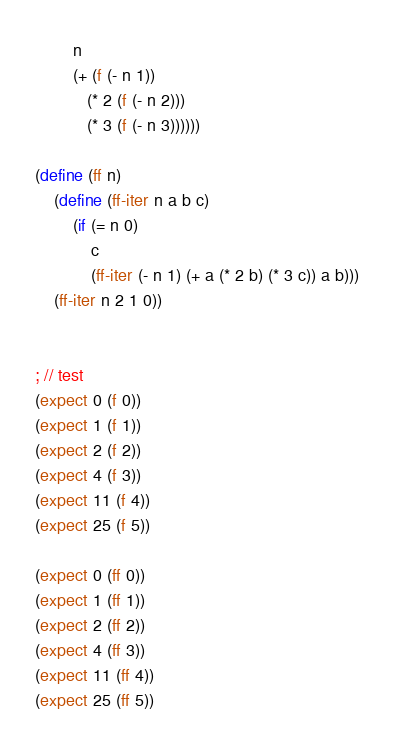<code> <loc_0><loc_0><loc_500><loc_500><_Scheme_>        n
        (+ (f (- n 1))
           (* 2 (f (- n 2)))
           (* 3 (f (- n 3))))))

(define (ff n)
    (define (ff-iter n a b c)
        (if (= n 0)
            c
            (ff-iter (- n 1) (+ a (* 2 b) (* 3 c)) a b)))
    (ff-iter n 2 1 0))


; // test
(expect 0 (f 0))
(expect 1 (f 1))
(expect 2 (f 2))
(expect 4 (f 3))
(expect 11 (f 4))
(expect 25 (f 5))

(expect 0 (ff 0))
(expect 1 (ff 1))
(expect 2 (ff 2))
(expect 4 (ff 3))
(expect 11 (ff 4))
(expect 25 (ff 5))

</code> 